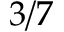<formula> <loc_0><loc_0><loc_500><loc_500>3 / 7</formula> 